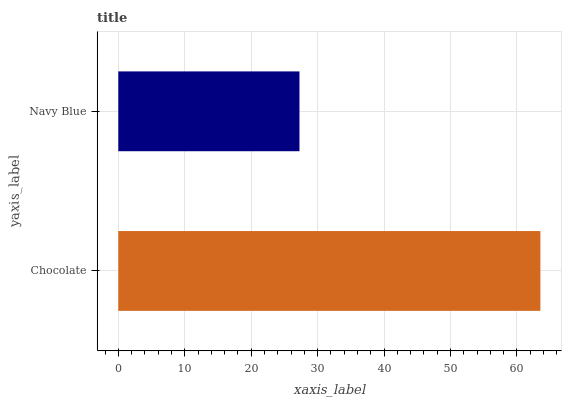Is Navy Blue the minimum?
Answer yes or no. Yes. Is Chocolate the maximum?
Answer yes or no. Yes. Is Navy Blue the maximum?
Answer yes or no. No. Is Chocolate greater than Navy Blue?
Answer yes or no. Yes. Is Navy Blue less than Chocolate?
Answer yes or no. Yes. Is Navy Blue greater than Chocolate?
Answer yes or no. No. Is Chocolate less than Navy Blue?
Answer yes or no. No. Is Chocolate the high median?
Answer yes or no. Yes. Is Navy Blue the low median?
Answer yes or no. Yes. Is Navy Blue the high median?
Answer yes or no. No. Is Chocolate the low median?
Answer yes or no. No. 